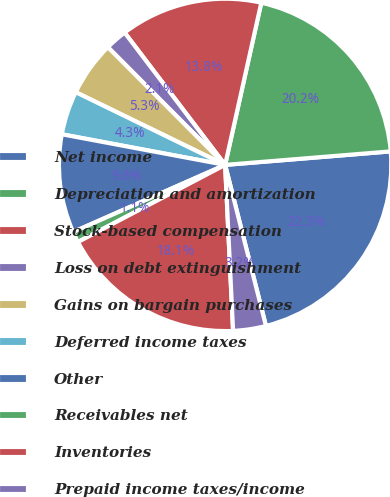<chart> <loc_0><loc_0><loc_500><loc_500><pie_chart><fcel>Net income<fcel>Depreciation and amortization<fcel>Stock-based compensation<fcel>Loss on debt extinguishment<fcel>Gains on bargain purchases<fcel>Deferred income taxes<fcel>Other<fcel>Receivables net<fcel>Inventories<fcel>Prepaid income taxes/income<nl><fcel>22.34%<fcel>20.21%<fcel>13.83%<fcel>2.13%<fcel>5.32%<fcel>4.26%<fcel>9.57%<fcel>1.06%<fcel>18.08%<fcel>3.19%<nl></chart> 